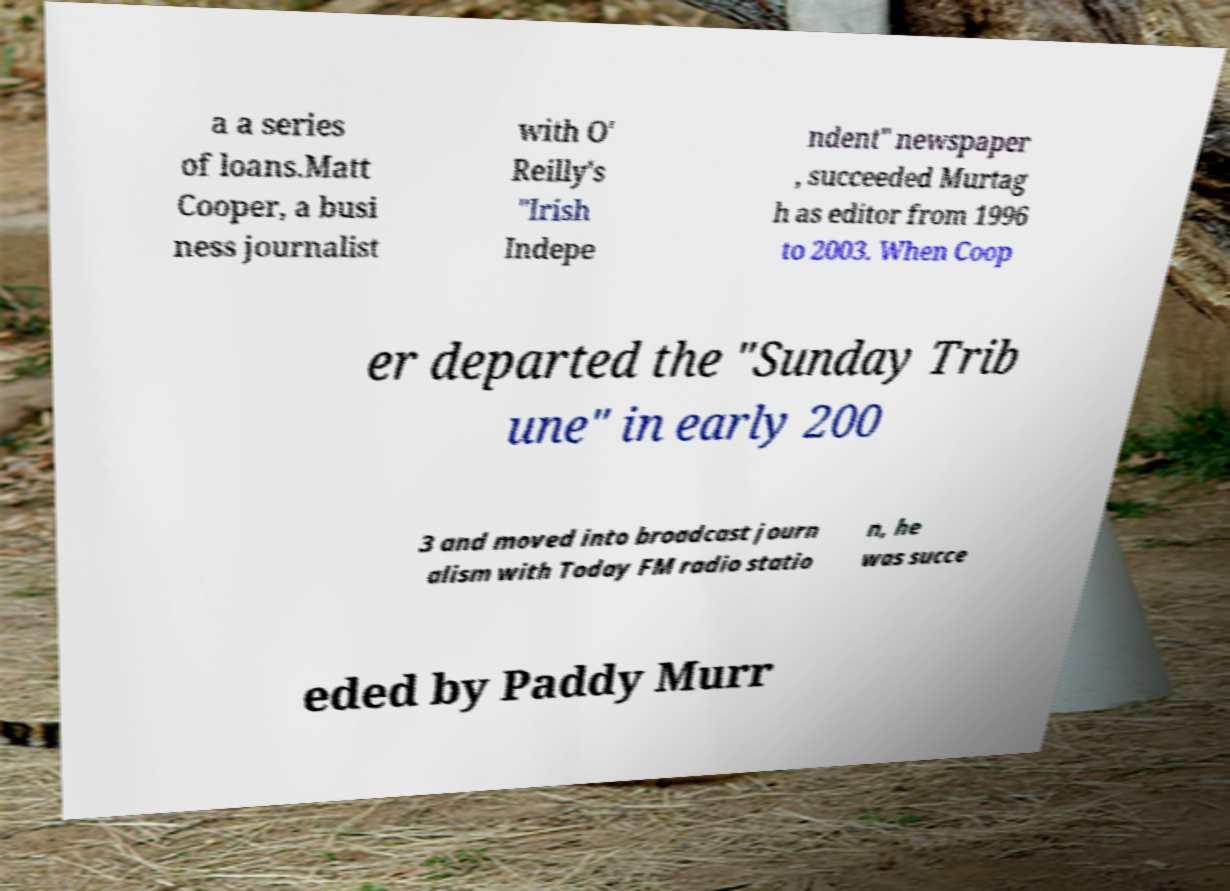What messages or text are displayed in this image? I need them in a readable, typed format. a a series of loans.Matt Cooper, a busi ness journalist with O' Reilly's "Irish Indepe ndent" newspaper , succeeded Murtag h as editor from 1996 to 2003. When Coop er departed the "Sunday Trib une" in early 200 3 and moved into broadcast journ alism with Today FM radio statio n, he was succe eded by Paddy Murr 